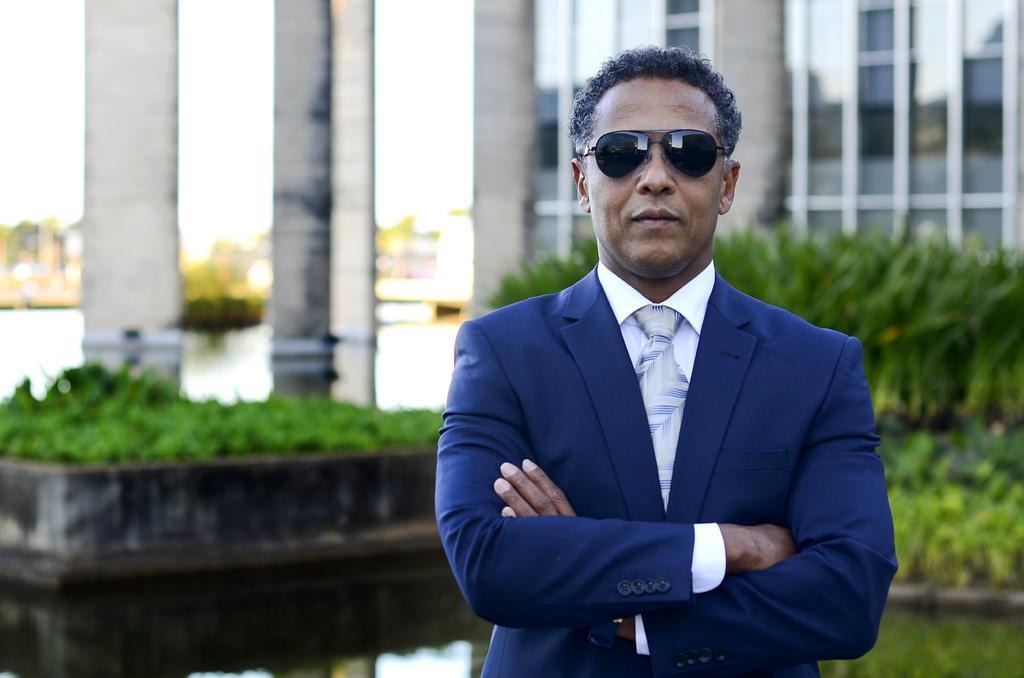Can you describe this image briefly? This picture is clicked outside. In the foreground there is a man wearing suit and goggles and standing on the ground. In the background there is a building and we can see the plants, pillars and some other objects. 